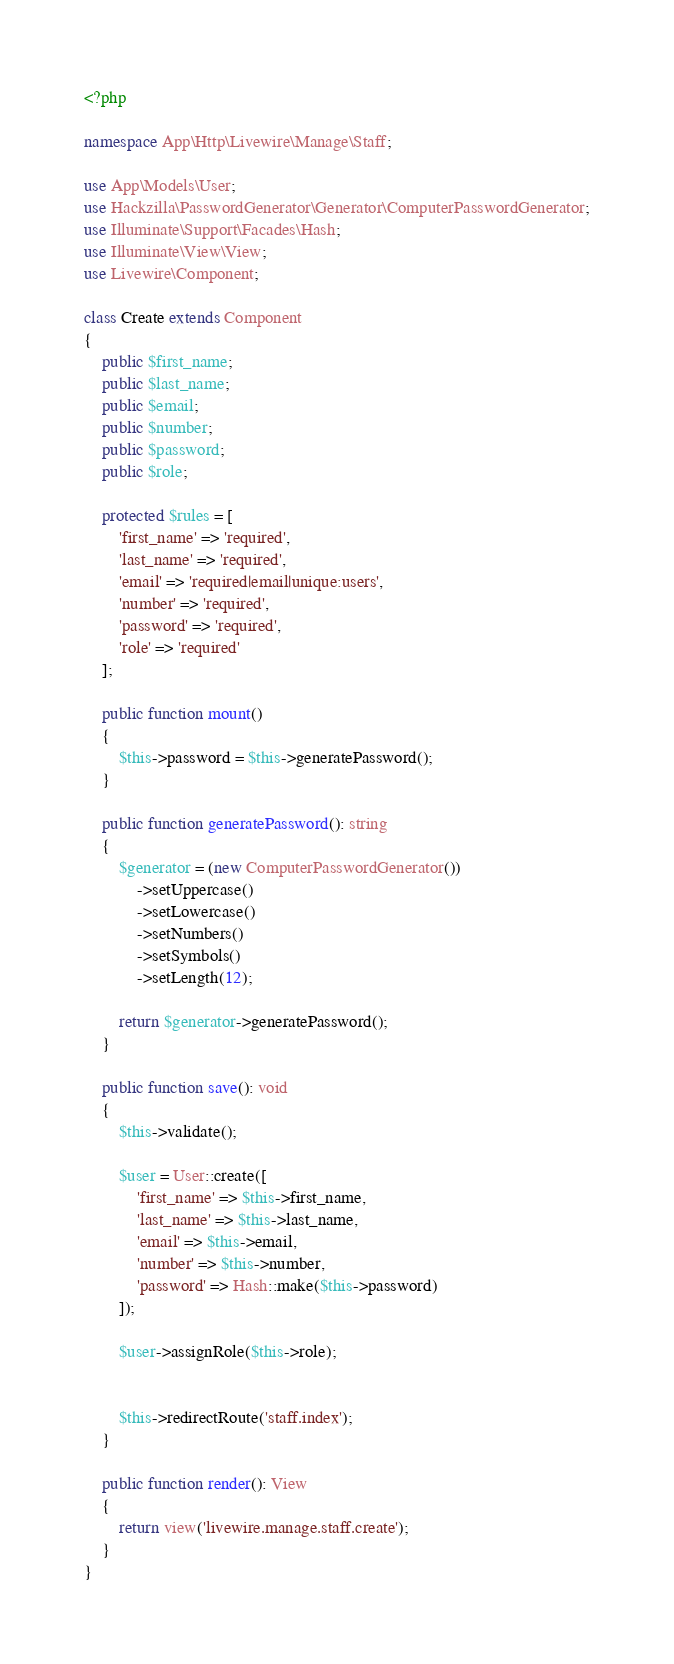Convert code to text. <code><loc_0><loc_0><loc_500><loc_500><_PHP_><?php

namespace App\Http\Livewire\Manage\Staff;

use App\Models\User;
use Hackzilla\PasswordGenerator\Generator\ComputerPasswordGenerator;
use Illuminate\Support\Facades\Hash;
use Illuminate\View\View;
use Livewire\Component;

class Create extends Component
{
    public $first_name;
    public $last_name;
    public $email;
    public $number;
    public $password;
    public $role;

    protected $rules = [
        'first_name' => 'required',
        'last_name' => 'required',
        'email' => 'required|email|unique:users',
        'number' => 'required',
        'password' => 'required',
        'role' => 'required'
    ];

    public function mount()
    {
        $this->password = $this->generatePassword();
    }

    public function generatePassword(): string
    {
        $generator = (new ComputerPasswordGenerator())
            ->setUppercase()
            ->setLowercase()
            ->setNumbers()
            ->setSymbols()
            ->setLength(12);

        return $generator->generatePassword();
    }

    public function save(): void
    {
        $this->validate();

        $user = User::create([
            'first_name' => $this->first_name,
            'last_name' => $this->last_name,
            'email' => $this->email,
            'number' => $this->number,
            'password' => Hash::make($this->password)
        ]);

        $user->assignRole($this->role);


        $this->redirectRoute('staff.index');
    }

    public function render(): View
    {
        return view('livewire.manage.staff.create');
    }
}
</code> 